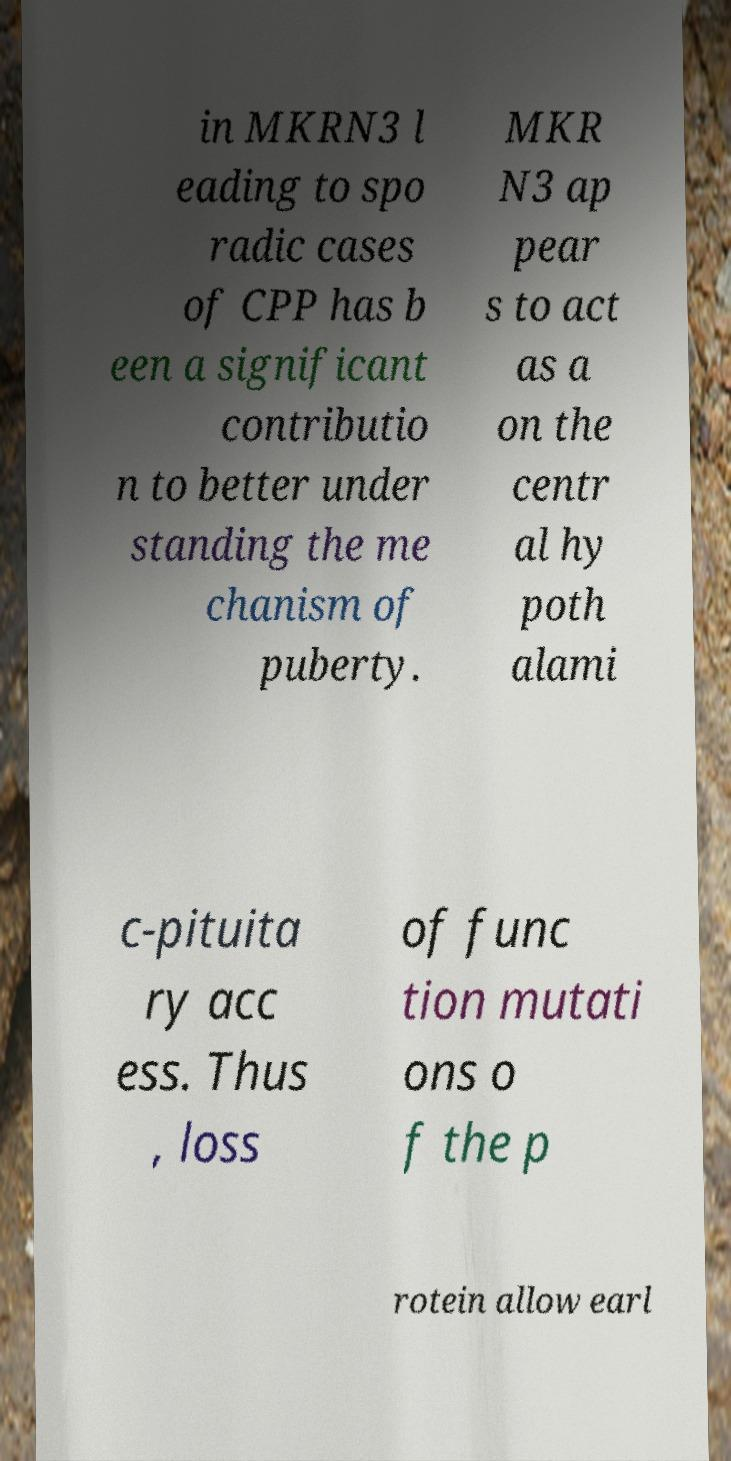For documentation purposes, I need the text within this image transcribed. Could you provide that? in MKRN3 l eading to spo radic cases of CPP has b een a significant contributio n to better under standing the me chanism of puberty. MKR N3 ap pear s to act as a on the centr al hy poth alami c-pituita ry acc ess. Thus , loss of func tion mutati ons o f the p rotein allow earl 